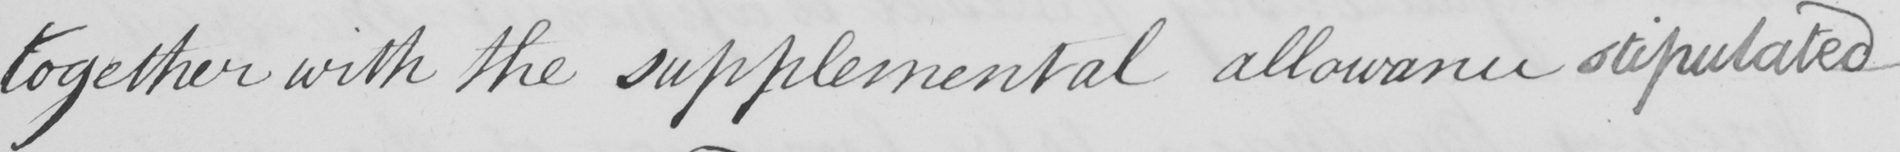Please provide the text content of this handwritten line. together with the supplemental allowance stipulated 